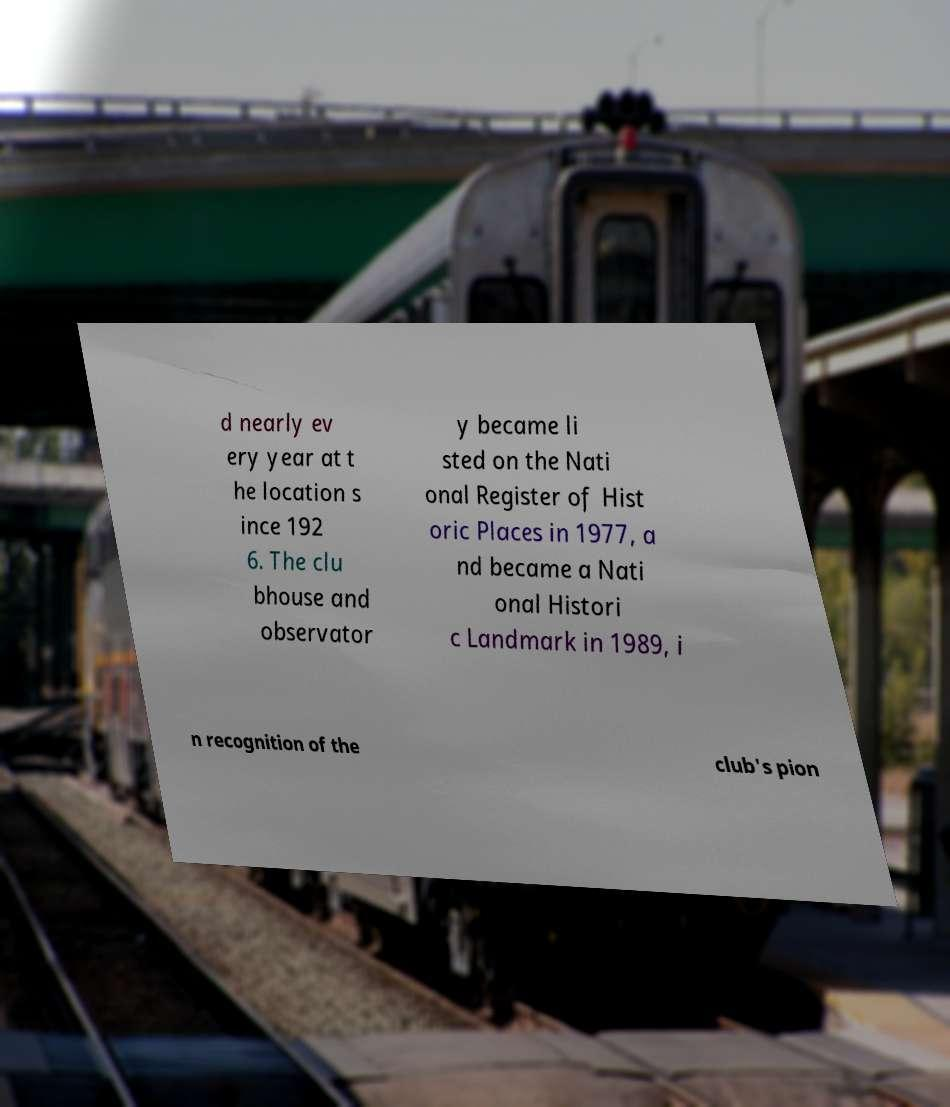There's text embedded in this image that I need extracted. Can you transcribe it verbatim? d nearly ev ery year at t he location s ince 192 6. The clu bhouse and observator y became li sted on the Nati onal Register of Hist oric Places in 1977, a nd became a Nati onal Histori c Landmark in 1989, i n recognition of the club's pion 